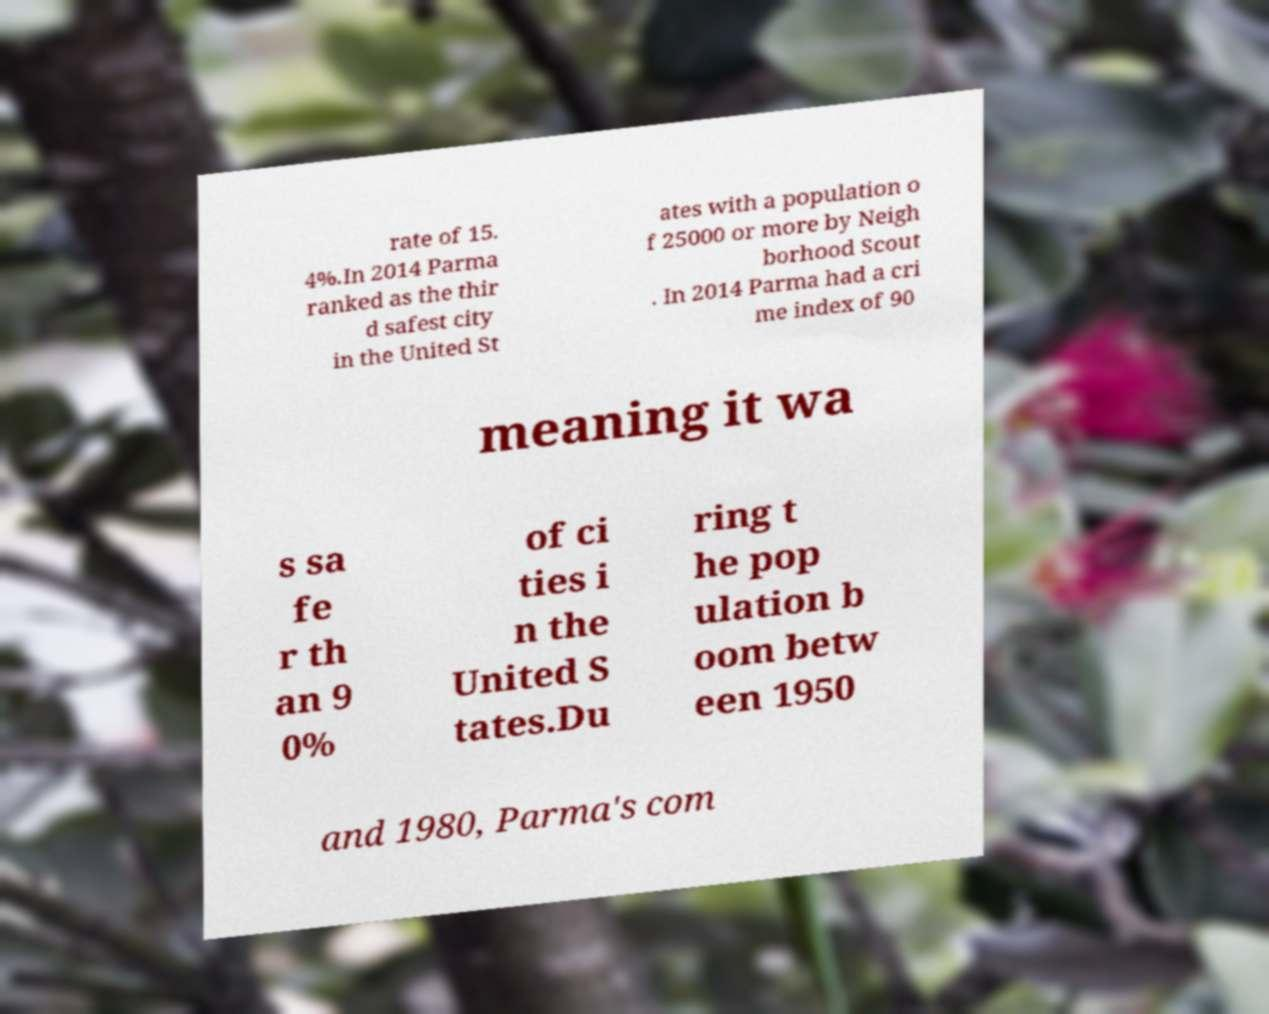I need the written content from this picture converted into text. Can you do that? rate of 15. 4%.In 2014 Parma ranked as the thir d safest city in the United St ates with a population o f 25000 or more by Neigh borhood Scout . In 2014 Parma had a cri me index of 90 meaning it wa s sa fe r th an 9 0% of ci ties i n the United S tates.Du ring t he pop ulation b oom betw een 1950 and 1980, Parma's com 